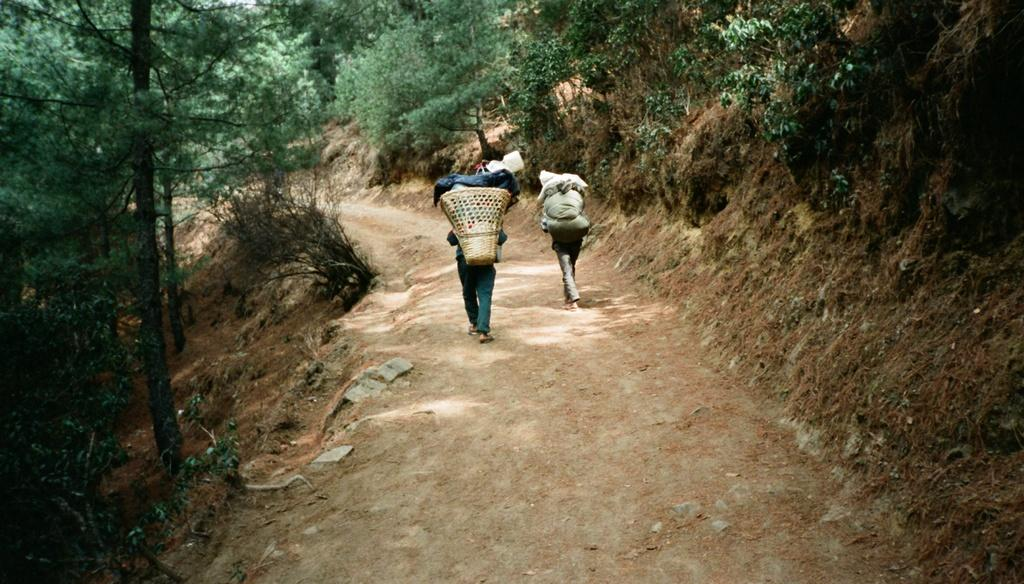Who is present in the image? There are people in the image. What are the people doing in the image? The people are carrying luggage. What can be seen in the background of the image? There are trees visible in the image. What type of church can be seen in the image? There is: There is no church present in the image; it only features people carrying luggage and trees in the background. 